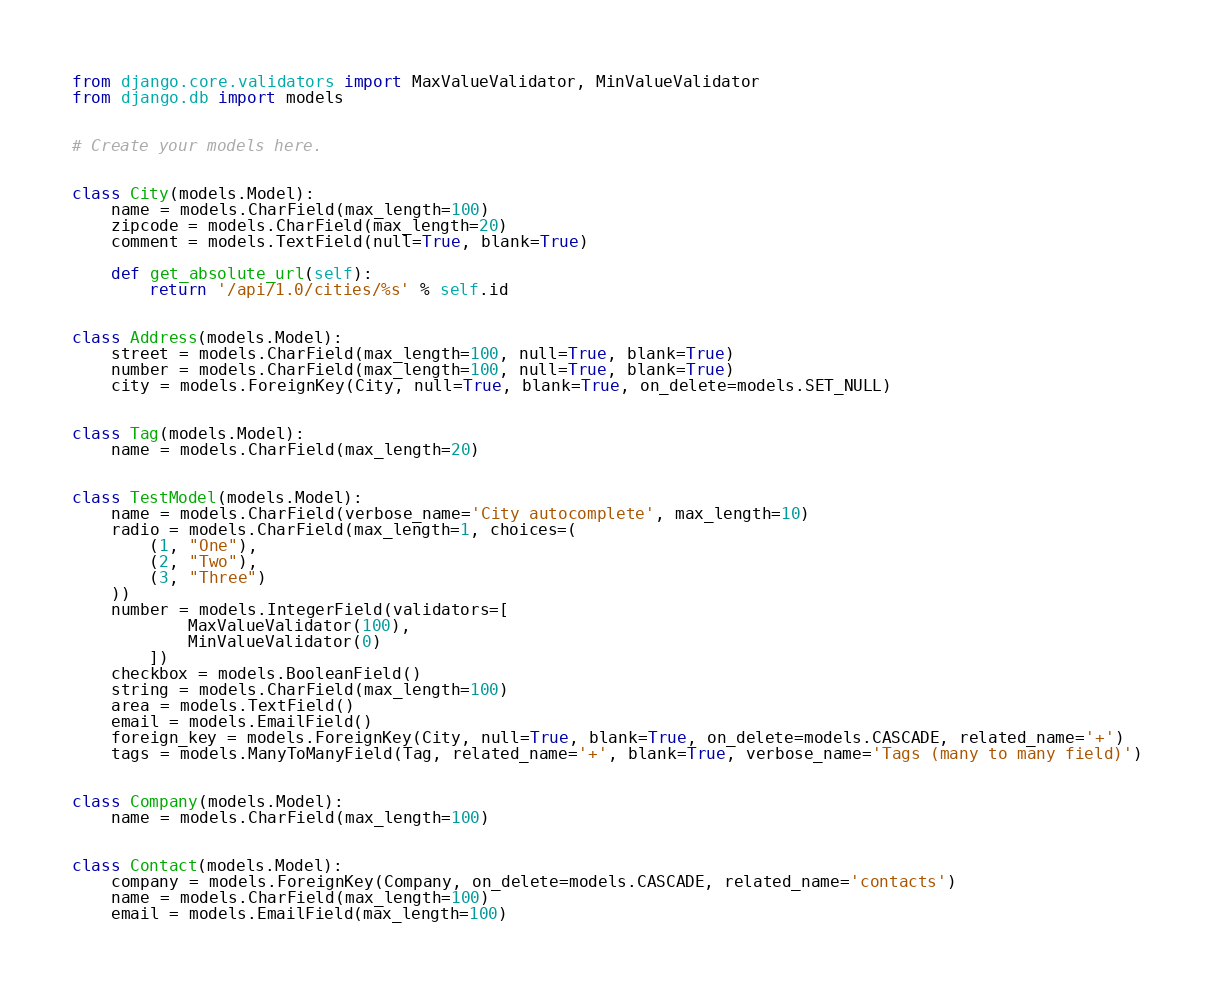Convert code to text. <code><loc_0><loc_0><loc_500><loc_500><_Python_>from django.core.validators import MaxValueValidator, MinValueValidator
from django.db import models


# Create your models here.


class City(models.Model):
    name = models.CharField(max_length=100)
    zipcode = models.CharField(max_length=20)
    comment = models.TextField(null=True, blank=True)

    def get_absolute_url(self):
        return '/api/1.0/cities/%s' % self.id


class Address(models.Model):
    street = models.CharField(max_length=100, null=True, blank=True)
    number = models.CharField(max_length=100, null=True, blank=True)
    city = models.ForeignKey(City, null=True, blank=True, on_delete=models.SET_NULL)


class Tag(models.Model):
    name = models.CharField(max_length=20)


class TestModel(models.Model):
    name = models.CharField(verbose_name='City autocomplete', max_length=10)
    radio = models.CharField(max_length=1, choices=(
        (1, "One"),
        (2, "Two"),
        (3, "Three")
    ))
    number = models.IntegerField(validators=[
            MaxValueValidator(100),
            MinValueValidator(0)
        ])
    checkbox = models.BooleanField()
    string = models.CharField(max_length=100)
    area = models.TextField()
    email = models.EmailField()
    foreign_key = models.ForeignKey(City, null=True, blank=True, on_delete=models.CASCADE, related_name='+')
    tags = models.ManyToManyField(Tag, related_name='+', blank=True, verbose_name='Tags (many to many field)')


class Company(models.Model):
    name = models.CharField(max_length=100)


class Contact(models.Model):
    company = models.ForeignKey(Company, on_delete=models.CASCADE, related_name='contacts')
    name = models.CharField(max_length=100)
    email = models.EmailField(max_length=100)
</code> 